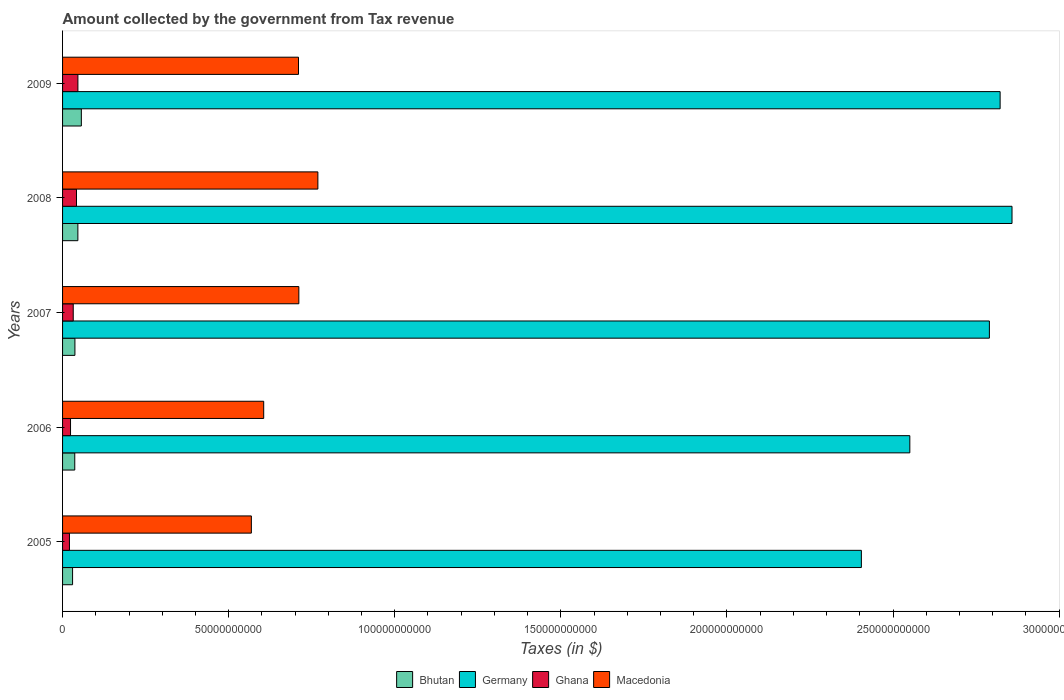Are the number of bars on each tick of the Y-axis equal?
Ensure brevity in your answer.  Yes. How many bars are there on the 3rd tick from the top?
Provide a short and direct response. 4. In how many cases, is the number of bars for a given year not equal to the number of legend labels?
Your answer should be compact. 0. What is the amount collected by the government from tax revenue in Ghana in 2006?
Give a very brief answer. 2.40e+09. Across all years, what is the maximum amount collected by the government from tax revenue in Germany?
Ensure brevity in your answer.  2.86e+11. Across all years, what is the minimum amount collected by the government from tax revenue in Ghana?
Your answer should be compact. 2.07e+09. In which year was the amount collected by the government from tax revenue in Bhutan minimum?
Your answer should be compact. 2005. What is the total amount collected by the government from tax revenue in Bhutan in the graph?
Provide a short and direct response. 2.07e+1. What is the difference between the amount collected by the government from tax revenue in Bhutan in 2005 and that in 2007?
Give a very brief answer. -7.05e+08. What is the difference between the amount collected by the government from tax revenue in Germany in 2005 and the amount collected by the government from tax revenue in Macedonia in 2008?
Provide a succinct answer. 1.64e+11. What is the average amount collected by the government from tax revenue in Macedonia per year?
Ensure brevity in your answer.  6.73e+1. In the year 2005, what is the difference between the amount collected by the government from tax revenue in Germany and amount collected by the government from tax revenue in Ghana?
Your answer should be very brief. 2.38e+11. What is the ratio of the amount collected by the government from tax revenue in Germany in 2006 to that in 2007?
Give a very brief answer. 0.91. Is the difference between the amount collected by the government from tax revenue in Germany in 2008 and 2009 greater than the difference between the amount collected by the government from tax revenue in Ghana in 2008 and 2009?
Offer a terse response. Yes. What is the difference between the highest and the second highest amount collected by the government from tax revenue in Macedonia?
Give a very brief answer. 5.73e+09. What is the difference between the highest and the lowest amount collected by the government from tax revenue in Germany?
Give a very brief answer. 4.54e+1. In how many years, is the amount collected by the government from tax revenue in Ghana greater than the average amount collected by the government from tax revenue in Ghana taken over all years?
Offer a very short reply. 2. Is the sum of the amount collected by the government from tax revenue in Macedonia in 2008 and 2009 greater than the maximum amount collected by the government from tax revenue in Germany across all years?
Ensure brevity in your answer.  No. What does the 2nd bar from the bottom in 2008 represents?
Offer a very short reply. Germany. Are all the bars in the graph horizontal?
Make the answer very short. Yes. What is the difference between two consecutive major ticks on the X-axis?
Provide a short and direct response. 5.00e+1. Where does the legend appear in the graph?
Keep it short and to the point. Bottom center. How many legend labels are there?
Your response must be concise. 4. How are the legend labels stacked?
Ensure brevity in your answer.  Horizontal. What is the title of the graph?
Your answer should be compact. Amount collected by the government from Tax revenue. What is the label or title of the X-axis?
Provide a succinct answer. Taxes (in $). What is the label or title of the Y-axis?
Give a very brief answer. Years. What is the Taxes (in $) in Bhutan in 2005?
Ensure brevity in your answer.  3.01e+09. What is the Taxes (in $) of Germany in 2005?
Keep it short and to the point. 2.40e+11. What is the Taxes (in $) of Ghana in 2005?
Your response must be concise. 2.07e+09. What is the Taxes (in $) of Macedonia in 2005?
Offer a terse response. 5.68e+1. What is the Taxes (in $) of Bhutan in 2006?
Provide a short and direct response. 3.67e+09. What is the Taxes (in $) of Germany in 2006?
Offer a terse response. 2.55e+11. What is the Taxes (in $) in Ghana in 2006?
Your answer should be very brief. 2.40e+09. What is the Taxes (in $) of Macedonia in 2006?
Your response must be concise. 6.05e+1. What is the Taxes (in $) of Bhutan in 2007?
Provide a succinct answer. 3.72e+09. What is the Taxes (in $) of Germany in 2007?
Your answer should be compact. 2.79e+11. What is the Taxes (in $) of Ghana in 2007?
Make the answer very short. 3.21e+09. What is the Taxes (in $) in Macedonia in 2007?
Your answer should be compact. 7.11e+1. What is the Taxes (in $) in Bhutan in 2008?
Make the answer very short. 4.61e+09. What is the Taxes (in $) in Germany in 2008?
Make the answer very short. 2.86e+11. What is the Taxes (in $) in Ghana in 2008?
Your answer should be very brief. 4.19e+09. What is the Taxes (in $) in Macedonia in 2008?
Make the answer very short. 7.69e+1. What is the Taxes (in $) in Bhutan in 2009?
Your response must be concise. 5.65e+09. What is the Taxes (in $) in Germany in 2009?
Your answer should be compact. 2.82e+11. What is the Taxes (in $) in Ghana in 2009?
Provide a short and direct response. 4.62e+09. What is the Taxes (in $) of Macedonia in 2009?
Provide a succinct answer. 7.10e+1. Across all years, what is the maximum Taxes (in $) of Bhutan?
Your answer should be compact. 5.65e+09. Across all years, what is the maximum Taxes (in $) in Germany?
Your response must be concise. 2.86e+11. Across all years, what is the maximum Taxes (in $) of Ghana?
Give a very brief answer. 4.62e+09. Across all years, what is the maximum Taxes (in $) of Macedonia?
Your answer should be compact. 7.69e+1. Across all years, what is the minimum Taxes (in $) in Bhutan?
Provide a succinct answer. 3.01e+09. Across all years, what is the minimum Taxes (in $) of Germany?
Provide a short and direct response. 2.40e+11. Across all years, what is the minimum Taxes (in $) of Ghana?
Offer a terse response. 2.07e+09. Across all years, what is the minimum Taxes (in $) of Macedonia?
Provide a succinct answer. 5.68e+1. What is the total Taxes (in $) in Bhutan in the graph?
Ensure brevity in your answer.  2.07e+1. What is the total Taxes (in $) of Germany in the graph?
Ensure brevity in your answer.  1.34e+12. What is the total Taxes (in $) of Ghana in the graph?
Keep it short and to the point. 1.65e+1. What is the total Taxes (in $) of Macedonia in the graph?
Your answer should be very brief. 3.36e+11. What is the difference between the Taxes (in $) in Bhutan in 2005 and that in 2006?
Keep it short and to the point. -6.59e+08. What is the difference between the Taxes (in $) in Germany in 2005 and that in 2006?
Offer a terse response. -1.46e+1. What is the difference between the Taxes (in $) of Ghana in 2005 and that in 2006?
Keep it short and to the point. -3.22e+08. What is the difference between the Taxes (in $) in Macedonia in 2005 and that in 2006?
Give a very brief answer. -3.72e+09. What is the difference between the Taxes (in $) of Bhutan in 2005 and that in 2007?
Provide a short and direct response. -7.05e+08. What is the difference between the Taxes (in $) in Germany in 2005 and that in 2007?
Provide a succinct answer. -3.85e+1. What is the difference between the Taxes (in $) of Ghana in 2005 and that in 2007?
Provide a short and direct response. -1.14e+09. What is the difference between the Taxes (in $) of Macedonia in 2005 and that in 2007?
Your answer should be very brief. -1.43e+1. What is the difference between the Taxes (in $) in Bhutan in 2005 and that in 2008?
Give a very brief answer. -1.59e+09. What is the difference between the Taxes (in $) in Germany in 2005 and that in 2008?
Your response must be concise. -4.54e+1. What is the difference between the Taxes (in $) in Ghana in 2005 and that in 2008?
Ensure brevity in your answer.  -2.12e+09. What is the difference between the Taxes (in $) of Macedonia in 2005 and that in 2008?
Your response must be concise. -2.00e+1. What is the difference between the Taxes (in $) in Bhutan in 2005 and that in 2009?
Provide a short and direct response. -2.64e+09. What is the difference between the Taxes (in $) in Germany in 2005 and that in 2009?
Your response must be concise. -4.18e+1. What is the difference between the Taxes (in $) in Ghana in 2005 and that in 2009?
Give a very brief answer. -2.54e+09. What is the difference between the Taxes (in $) of Macedonia in 2005 and that in 2009?
Your answer should be compact. -1.42e+1. What is the difference between the Taxes (in $) in Bhutan in 2006 and that in 2007?
Provide a succinct answer. -4.57e+07. What is the difference between the Taxes (in $) of Germany in 2006 and that in 2007?
Offer a terse response. -2.40e+1. What is the difference between the Taxes (in $) of Ghana in 2006 and that in 2007?
Your response must be concise. -8.18e+08. What is the difference between the Taxes (in $) in Macedonia in 2006 and that in 2007?
Your answer should be very brief. -1.06e+1. What is the difference between the Taxes (in $) of Bhutan in 2006 and that in 2008?
Offer a very short reply. -9.34e+08. What is the difference between the Taxes (in $) in Germany in 2006 and that in 2008?
Ensure brevity in your answer.  -3.08e+1. What is the difference between the Taxes (in $) in Ghana in 2006 and that in 2008?
Give a very brief answer. -1.80e+09. What is the difference between the Taxes (in $) in Macedonia in 2006 and that in 2008?
Provide a short and direct response. -1.63e+1. What is the difference between the Taxes (in $) in Bhutan in 2006 and that in 2009?
Offer a terse response. -1.98e+09. What is the difference between the Taxes (in $) of Germany in 2006 and that in 2009?
Provide a succinct answer. -2.72e+1. What is the difference between the Taxes (in $) of Ghana in 2006 and that in 2009?
Your answer should be very brief. -2.22e+09. What is the difference between the Taxes (in $) in Macedonia in 2006 and that in 2009?
Offer a very short reply. -1.05e+1. What is the difference between the Taxes (in $) in Bhutan in 2007 and that in 2008?
Your answer should be compact. -8.88e+08. What is the difference between the Taxes (in $) of Germany in 2007 and that in 2008?
Your answer should be compact. -6.81e+09. What is the difference between the Taxes (in $) of Ghana in 2007 and that in 2008?
Ensure brevity in your answer.  -9.80e+08. What is the difference between the Taxes (in $) of Macedonia in 2007 and that in 2008?
Provide a succinct answer. -5.73e+09. What is the difference between the Taxes (in $) in Bhutan in 2007 and that in 2009?
Make the answer very short. -1.94e+09. What is the difference between the Taxes (in $) of Germany in 2007 and that in 2009?
Your answer should be very brief. -3.23e+09. What is the difference between the Taxes (in $) in Ghana in 2007 and that in 2009?
Ensure brevity in your answer.  -1.40e+09. What is the difference between the Taxes (in $) of Macedonia in 2007 and that in 2009?
Keep it short and to the point. 1.05e+08. What is the difference between the Taxes (in $) of Bhutan in 2008 and that in 2009?
Keep it short and to the point. -1.05e+09. What is the difference between the Taxes (in $) of Germany in 2008 and that in 2009?
Ensure brevity in your answer.  3.58e+09. What is the difference between the Taxes (in $) in Ghana in 2008 and that in 2009?
Provide a short and direct response. -4.22e+08. What is the difference between the Taxes (in $) in Macedonia in 2008 and that in 2009?
Ensure brevity in your answer.  5.83e+09. What is the difference between the Taxes (in $) in Bhutan in 2005 and the Taxes (in $) in Germany in 2006?
Your answer should be compact. -2.52e+11. What is the difference between the Taxes (in $) of Bhutan in 2005 and the Taxes (in $) of Ghana in 2006?
Your answer should be very brief. 6.19e+08. What is the difference between the Taxes (in $) of Bhutan in 2005 and the Taxes (in $) of Macedonia in 2006?
Provide a short and direct response. -5.75e+1. What is the difference between the Taxes (in $) of Germany in 2005 and the Taxes (in $) of Ghana in 2006?
Make the answer very short. 2.38e+11. What is the difference between the Taxes (in $) in Germany in 2005 and the Taxes (in $) in Macedonia in 2006?
Offer a very short reply. 1.80e+11. What is the difference between the Taxes (in $) in Ghana in 2005 and the Taxes (in $) in Macedonia in 2006?
Offer a very short reply. -5.85e+1. What is the difference between the Taxes (in $) of Bhutan in 2005 and the Taxes (in $) of Germany in 2007?
Offer a terse response. -2.76e+11. What is the difference between the Taxes (in $) of Bhutan in 2005 and the Taxes (in $) of Ghana in 2007?
Keep it short and to the point. -1.99e+08. What is the difference between the Taxes (in $) in Bhutan in 2005 and the Taxes (in $) in Macedonia in 2007?
Your answer should be very brief. -6.81e+1. What is the difference between the Taxes (in $) of Germany in 2005 and the Taxes (in $) of Ghana in 2007?
Your answer should be compact. 2.37e+11. What is the difference between the Taxes (in $) in Germany in 2005 and the Taxes (in $) in Macedonia in 2007?
Offer a very short reply. 1.69e+11. What is the difference between the Taxes (in $) of Ghana in 2005 and the Taxes (in $) of Macedonia in 2007?
Your answer should be very brief. -6.91e+1. What is the difference between the Taxes (in $) of Bhutan in 2005 and the Taxes (in $) of Germany in 2008?
Your answer should be very brief. -2.83e+11. What is the difference between the Taxes (in $) of Bhutan in 2005 and the Taxes (in $) of Ghana in 2008?
Provide a succinct answer. -1.18e+09. What is the difference between the Taxes (in $) in Bhutan in 2005 and the Taxes (in $) in Macedonia in 2008?
Offer a terse response. -7.38e+1. What is the difference between the Taxes (in $) in Germany in 2005 and the Taxes (in $) in Ghana in 2008?
Your answer should be very brief. 2.36e+11. What is the difference between the Taxes (in $) in Germany in 2005 and the Taxes (in $) in Macedonia in 2008?
Your answer should be compact. 1.64e+11. What is the difference between the Taxes (in $) in Ghana in 2005 and the Taxes (in $) in Macedonia in 2008?
Provide a short and direct response. -7.48e+1. What is the difference between the Taxes (in $) in Bhutan in 2005 and the Taxes (in $) in Germany in 2009?
Offer a terse response. -2.79e+11. What is the difference between the Taxes (in $) in Bhutan in 2005 and the Taxes (in $) in Ghana in 2009?
Your answer should be compact. -1.60e+09. What is the difference between the Taxes (in $) in Bhutan in 2005 and the Taxes (in $) in Macedonia in 2009?
Give a very brief answer. -6.80e+1. What is the difference between the Taxes (in $) of Germany in 2005 and the Taxes (in $) of Ghana in 2009?
Your response must be concise. 2.36e+11. What is the difference between the Taxes (in $) in Germany in 2005 and the Taxes (in $) in Macedonia in 2009?
Provide a succinct answer. 1.69e+11. What is the difference between the Taxes (in $) of Ghana in 2005 and the Taxes (in $) of Macedonia in 2009?
Keep it short and to the point. -6.89e+1. What is the difference between the Taxes (in $) of Bhutan in 2006 and the Taxes (in $) of Germany in 2007?
Make the answer very short. -2.75e+11. What is the difference between the Taxes (in $) in Bhutan in 2006 and the Taxes (in $) in Ghana in 2007?
Provide a succinct answer. 4.60e+08. What is the difference between the Taxes (in $) of Bhutan in 2006 and the Taxes (in $) of Macedonia in 2007?
Offer a very short reply. -6.75e+1. What is the difference between the Taxes (in $) in Germany in 2006 and the Taxes (in $) in Ghana in 2007?
Offer a very short reply. 2.52e+11. What is the difference between the Taxes (in $) of Germany in 2006 and the Taxes (in $) of Macedonia in 2007?
Give a very brief answer. 1.84e+11. What is the difference between the Taxes (in $) in Ghana in 2006 and the Taxes (in $) in Macedonia in 2007?
Keep it short and to the point. -6.87e+1. What is the difference between the Taxes (in $) in Bhutan in 2006 and the Taxes (in $) in Germany in 2008?
Give a very brief answer. -2.82e+11. What is the difference between the Taxes (in $) in Bhutan in 2006 and the Taxes (in $) in Ghana in 2008?
Your answer should be compact. -5.20e+08. What is the difference between the Taxes (in $) in Bhutan in 2006 and the Taxes (in $) in Macedonia in 2008?
Give a very brief answer. -7.32e+1. What is the difference between the Taxes (in $) in Germany in 2006 and the Taxes (in $) in Ghana in 2008?
Provide a short and direct response. 2.51e+11. What is the difference between the Taxes (in $) in Germany in 2006 and the Taxes (in $) in Macedonia in 2008?
Ensure brevity in your answer.  1.78e+11. What is the difference between the Taxes (in $) in Ghana in 2006 and the Taxes (in $) in Macedonia in 2008?
Offer a terse response. -7.45e+1. What is the difference between the Taxes (in $) in Bhutan in 2006 and the Taxes (in $) in Germany in 2009?
Ensure brevity in your answer.  -2.79e+11. What is the difference between the Taxes (in $) in Bhutan in 2006 and the Taxes (in $) in Ghana in 2009?
Make the answer very short. -9.43e+08. What is the difference between the Taxes (in $) of Bhutan in 2006 and the Taxes (in $) of Macedonia in 2009?
Make the answer very short. -6.73e+1. What is the difference between the Taxes (in $) of Germany in 2006 and the Taxes (in $) of Ghana in 2009?
Give a very brief answer. 2.50e+11. What is the difference between the Taxes (in $) of Germany in 2006 and the Taxes (in $) of Macedonia in 2009?
Keep it short and to the point. 1.84e+11. What is the difference between the Taxes (in $) of Ghana in 2006 and the Taxes (in $) of Macedonia in 2009?
Give a very brief answer. -6.86e+1. What is the difference between the Taxes (in $) of Bhutan in 2007 and the Taxes (in $) of Germany in 2008?
Your answer should be very brief. -2.82e+11. What is the difference between the Taxes (in $) of Bhutan in 2007 and the Taxes (in $) of Ghana in 2008?
Your answer should be very brief. -4.75e+08. What is the difference between the Taxes (in $) in Bhutan in 2007 and the Taxes (in $) in Macedonia in 2008?
Ensure brevity in your answer.  -7.31e+1. What is the difference between the Taxes (in $) of Germany in 2007 and the Taxes (in $) of Ghana in 2008?
Your answer should be very brief. 2.75e+11. What is the difference between the Taxes (in $) in Germany in 2007 and the Taxes (in $) in Macedonia in 2008?
Provide a short and direct response. 2.02e+11. What is the difference between the Taxes (in $) in Ghana in 2007 and the Taxes (in $) in Macedonia in 2008?
Your response must be concise. -7.36e+1. What is the difference between the Taxes (in $) of Bhutan in 2007 and the Taxes (in $) of Germany in 2009?
Offer a terse response. -2.79e+11. What is the difference between the Taxes (in $) in Bhutan in 2007 and the Taxes (in $) in Ghana in 2009?
Ensure brevity in your answer.  -8.97e+08. What is the difference between the Taxes (in $) in Bhutan in 2007 and the Taxes (in $) in Macedonia in 2009?
Make the answer very short. -6.73e+1. What is the difference between the Taxes (in $) in Germany in 2007 and the Taxes (in $) in Ghana in 2009?
Offer a terse response. 2.74e+11. What is the difference between the Taxes (in $) of Germany in 2007 and the Taxes (in $) of Macedonia in 2009?
Your response must be concise. 2.08e+11. What is the difference between the Taxes (in $) in Ghana in 2007 and the Taxes (in $) in Macedonia in 2009?
Ensure brevity in your answer.  -6.78e+1. What is the difference between the Taxes (in $) in Bhutan in 2008 and the Taxes (in $) in Germany in 2009?
Keep it short and to the point. -2.78e+11. What is the difference between the Taxes (in $) of Bhutan in 2008 and the Taxes (in $) of Ghana in 2009?
Offer a very short reply. -8.64e+06. What is the difference between the Taxes (in $) in Bhutan in 2008 and the Taxes (in $) in Macedonia in 2009?
Ensure brevity in your answer.  -6.64e+1. What is the difference between the Taxes (in $) in Germany in 2008 and the Taxes (in $) in Ghana in 2009?
Ensure brevity in your answer.  2.81e+11. What is the difference between the Taxes (in $) in Germany in 2008 and the Taxes (in $) in Macedonia in 2009?
Your answer should be very brief. 2.15e+11. What is the difference between the Taxes (in $) in Ghana in 2008 and the Taxes (in $) in Macedonia in 2009?
Keep it short and to the point. -6.68e+1. What is the average Taxes (in $) of Bhutan per year?
Provide a succinct answer. 4.13e+09. What is the average Taxes (in $) of Germany per year?
Provide a short and direct response. 2.69e+11. What is the average Taxes (in $) of Ghana per year?
Provide a short and direct response. 3.30e+09. What is the average Taxes (in $) in Macedonia per year?
Your answer should be very brief. 6.73e+1. In the year 2005, what is the difference between the Taxes (in $) of Bhutan and Taxes (in $) of Germany?
Offer a terse response. -2.37e+11. In the year 2005, what is the difference between the Taxes (in $) in Bhutan and Taxes (in $) in Ghana?
Keep it short and to the point. 9.40e+08. In the year 2005, what is the difference between the Taxes (in $) of Bhutan and Taxes (in $) of Macedonia?
Give a very brief answer. -5.38e+1. In the year 2005, what is the difference between the Taxes (in $) in Germany and Taxes (in $) in Ghana?
Your answer should be very brief. 2.38e+11. In the year 2005, what is the difference between the Taxes (in $) in Germany and Taxes (in $) in Macedonia?
Your response must be concise. 1.84e+11. In the year 2005, what is the difference between the Taxes (in $) of Ghana and Taxes (in $) of Macedonia?
Your answer should be compact. -5.48e+1. In the year 2006, what is the difference between the Taxes (in $) in Bhutan and Taxes (in $) in Germany?
Provide a short and direct response. -2.51e+11. In the year 2006, what is the difference between the Taxes (in $) in Bhutan and Taxes (in $) in Ghana?
Your response must be concise. 1.28e+09. In the year 2006, what is the difference between the Taxes (in $) of Bhutan and Taxes (in $) of Macedonia?
Ensure brevity in your answer.  -5.69e+1. In the year 2006, what is the difference between the Taxes (in $) of Germany and Taxes (in $) of Ghana?
Provide a short and direct response. 2.53e+11. In the year 2006, what is the difference between the Taxes (in $) in Germany and Taxes (in $) in Macedonia?
Provide a short and direct response. 1.95e+11. In the year 2006, what is the difference between the Taxes (in $) of Ghana and Taxes (in $) of Macedonia?
Offer a terse response. -5.82e+1. In the year 2007, what is the difference between the Taxes (in $) in Bhutan and Taxes (in $) in Germany?
Keep it short and to the point. -2.75e+11. In the year 2007, what is the difference between the Taxes (in $) in Bhutan and Taxes (in $) in Ghana?
Ensure brevity in your answer.  5.06e+08. In the year 2007, what is the difference between the Taxes (in $) in Bhutan and Taxes (in $) in Macedonia?
Offer a very short reply. -6.74e+1. In the year 2007, what is the difference between the Taxes (in $) in Germany and Taxes (in $) in Ghana?
Offer a terse response. 2.76e+11. In the year 2007, what is the difference between the Taxes (in $) of Germany and Taxes (in $) of Macedonia?
Make the answer very short. 2.08e+11. In the year 2007, what is the difference between the Taxes (in $) of Ghana and Taxes (in $) of Macedonia?
Your response must be concise. -6.79e+1. In the year 2008, what is the difference between the Taxes (in $) in Bhutan and Taxes (in $) in Germany?
Your answer should be compact. -2.81e+11. In the year 2008, what is the difference between the Taxes (in $) of Bhutan and Taxes (in $) of Ghana?
Your answer should be compact. 4.14e+08. In the year 2008, what is the difference between the Taxes (in $) of Bhutan and Taxes (in $) of Macedonia?
Your response must be concise. -7.22e+1. In the year 2008, what is the difference between the Taxes (in $) of Germany and Taxes (in $) of Ghana?
Your answer should be very brief. 2.82e+11. In the year 2008, what is the difference between the Taxes (in $) of Germany and Taxes (in $) of Macedonia?
Offer a terse response. 2.09e+11. In the year 2008, what is the difference between the Taxes (in $) of Ghana and Taxes (in $) of Macedonia?
Keep it short and to the point. -7.27e+1. In the year 2009, what is the difference between the Taxes (in $) in Bhutan and Taxes (in $) in Germany?
Provide a succinct answer. -2.77e+11. In the year 2009, what is the difference between the Taxes (in $) in Bhutan and Taxes (in $) in Ghana?
Make the answer very short. 1.04e+09. In the year 2009, what is the difference between the Taxes (in $) of Bhutan and Taxes (in $) of Macedonia?
Your answer should be very brief. -6.54e+1. In the year 2009, what is the difference between the Taxes (in $) in Germany and Taxes (in $) in Ghana?
Your answer should be very brief. 2.78e+11. In the year 2009, what is the difference between the Taxes (in $) in Germany and Taxes (in $) in Macedonia?
Your answer should be very brief. 2.11e+11. In the year 2009, what is the difference between the Taxes (in $) in Ghana and Taxes (in $) in Macedonia?
Provide a short and direct response. -6.64e+1. What is the ratio of the Taxes (in $) in Bhutan in 2005 to that in 2006?
Offer a very short reply. 0.82. What is the ratio of the Taxes (in $) in Germany in 2005 to that in 2006?
Give a very brief answer. 0.94. What is the ratio of the Taxes (in $) in Ghana in 2005 to that in 2006?
Your answer should be very brief. 0.87. What is the ratio of the Taxes (in $) in Macedonia in 2005 to that in 2006?
Your answer should be very brief. 0.94. What is the ratio of the Taxes (in $) in Bhutan in 2005 to that in 2007?
Your response must be concise. 0.81. What is the ratio of the Taxes (in $) of Germany in 2005 to that in 2007?
Ensure brevity in your answer.  0.86. What is the ratio of the Taxes (in $) in Ghana in 2005 to that in 2007?
Give a very brief answer. 0.65. What is the ratio of the Taxes (in $) in Macedonia in 2005 to that in 2007?
Provide a succinct answer. 0.8. What is the ratio of the Taxes (in $) in Bhutan in 2005 to that in 2008?
Offer a terse response. 0.65. What is the ratio of the Taxes (in $) of Germany in 2005 to that in 2008?
Your answer should be very brief. 0.84. What is the ratio of the Taxes (in $) in Ghana in 2005 to that in 2008?
Ensure brevity in your answer.  0.49. What is the ratio of the Taxes (in $) of Macedonia in 2005 to that in 2008?
Keep it short and to the point. 0.74. What is the ratio of the Taxes (in $) in Bhutan in 2005 to that in 2009?
Your answer should be compact. 0.53. What is the ratio of the Taxes (in $) of Germany in 2005 to that in 2009?
Give a very brief answer. 0.85. What is the ratio of the Taxes (in $) of Ghana in 2005 to that in 2009?
Offer a very short reply. 0.45. What is the ratio of the Taxes (in $) in Macedonia in 2005 to that in 2009?
Keep it short and to the point. 0.8. What is the ratio of the Taxes (in $) in Bhutan in 2006 to that in 2007?
Your answer should be compact. 0.99. What is the ratio of the Taxes (in $) of Germany in 2006 to that in 2007?
Your answer should be very brief. 0.91. What is the ratio of the Taxes (in $) of Ghana in 2006 to that in 2007?
Keep it short and to the point. 0.75. What is the ratio of the Taxes (in $) of Macedonia in 2006 to that in 2007?
Make the answer very short. 0.85. What is the ratio of the Taxes (in $) of Bhutan in 2006 to that in 2008?
Provide a short and direct response. 0.8. What is the ratio of the Taxes (in $) of Germany in 2006 to that in 2008?
Keep it short and to the point. 0.89. What is the ratio of the Taxes (in $) of Ghana in 2006 to that in 2008?
Your answer should be compact. 0.57. What is the ratio of the Taxes (in $) in Macedonia in 2006 to that in 2008?
Your answer should be compact. 0.79. What is the ratio of the Taxes (in $) in Bhutan in 2006 to that in 2009?
Make the answer very short. 0.65. What is the ratio of the Taxes (in $) of Germany in 2006 to that in 2009?
Offer a very short reply. 0.9. What is the ratio of the Taxes (in $) in Ghana in 2006 to that in 2009?
Offer a very short reply. 0.52. What is the ratio of the Taxes (in $) of Macedonia in 2006 to that in 2009?
Keep it short and to the point. 0.85. What is the ratio of the Taxes (in $) of Bhutan in 2007 to that in 2008?
Offer a terse response. 0.81. What is the ratio of the Taxes (in $) of Germany in 2007 to that in 2008?
Provide a succinct answer. 0.98. What is the ratio of the Taxes (in $) of Ghana in 2007 to that in 2008?
Provide a short and direct response. 0.77. What is the ratio of the Taxes (in $) in Macedonia in 2007 to that in 2008?
Your answer should be compact. 0.93. What is the ratio of the Taxes (in $) in Bhutan in 2007 to that in 2009?
Your response must be concise. 0.66. What is the ratio of the Taxes (in $) of Ghana in 2007 to that in 2009?
Your answer should be compact. 0.7. What is the ratio of the Taxes (in $) of Macedonia in 2007 to that in 2009?
Provide a succinct answer. 1. What is the ratio of the Taxes (in $) in Bhutan in 2008 to that in 2009?
Provide a succinct answer. 0.81. What is the ratio of the Taxes (in $) of Germany in 2008 to that in 2009?
Your answer should be very brief. 1.01. What is the ratio of the Taxes (in $) of Ghana in 2008 to that in 2009?
Give a very brief answer. 0.91. What is the ratio of the Taxes (in $) in Macedonia in 2008 to that in 2009?
Your response must be concise. 1.08. What is the difference between the highest and the second highest Taxes (in $) in Bhutan?
Ensure brevity in your answer.  1.05e+09. What is the difference between the highest and the second highest Taxes (in $) of Germany?
Your answer should be very brief. 3.58e+09. What is the difference between the highest and the second highest Taxes (in $) of Ghana?
Give a very brief answer. 4.22e+08. What is the difference between the highest and the second highest Taxes (in $) in Macedonia?
Keep it short and to the point. 5.73e+09. What is the difference between the highest and the lowest Taxes (in $) in Bhutan?
Make the answer very short. 2.64e+09. What is the difference between the highest and the lowest Taxes (in $) in Germany?
Give a very brief answer. 4.54e+1. What is the difference between the highest and the lowest Taxes (in $) in Ghana?
Offer a terse response. 2.54e+09. What is the difference between the highest and the lowest Taxes (in $) of Macedonia?
Your response must be concise. 2.00e+1. 